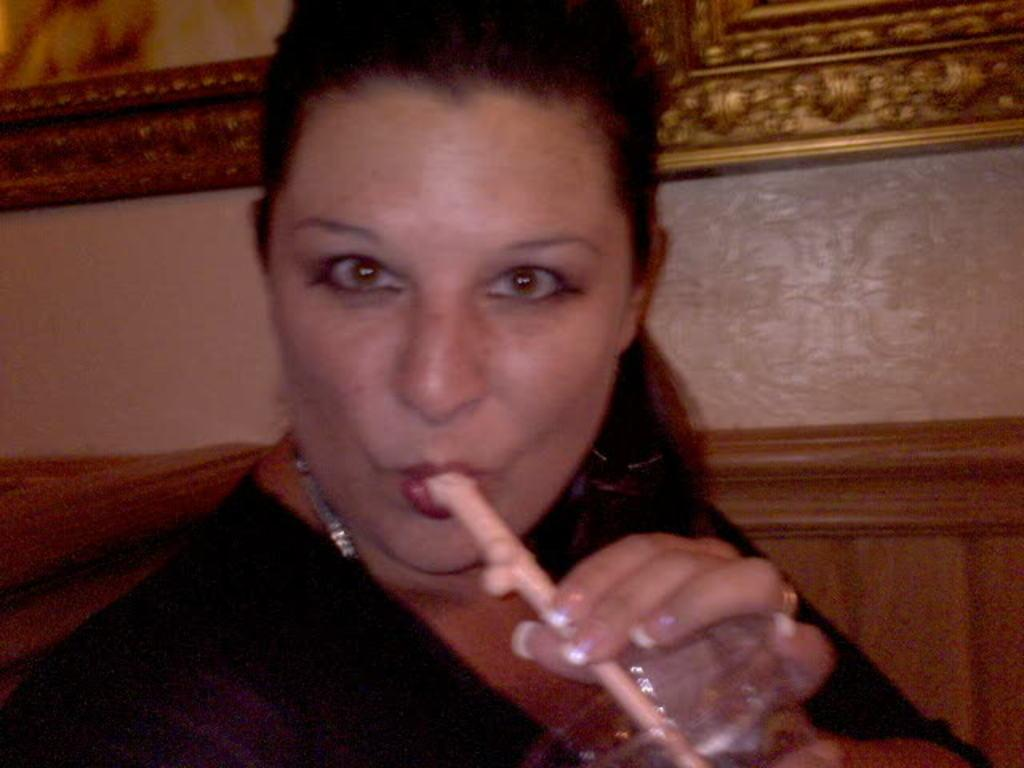Who is the main subject in the image? There is a woman in the image. What is the woman doing in the image? The woman is drinking something with a straw. What can be seen in the background of the image? There is a wall visible in the background of the image. What type of pet does the woman's aunt have in the image? There is no mention of an aunt or a pet in the image, so we cannot answer this question. 